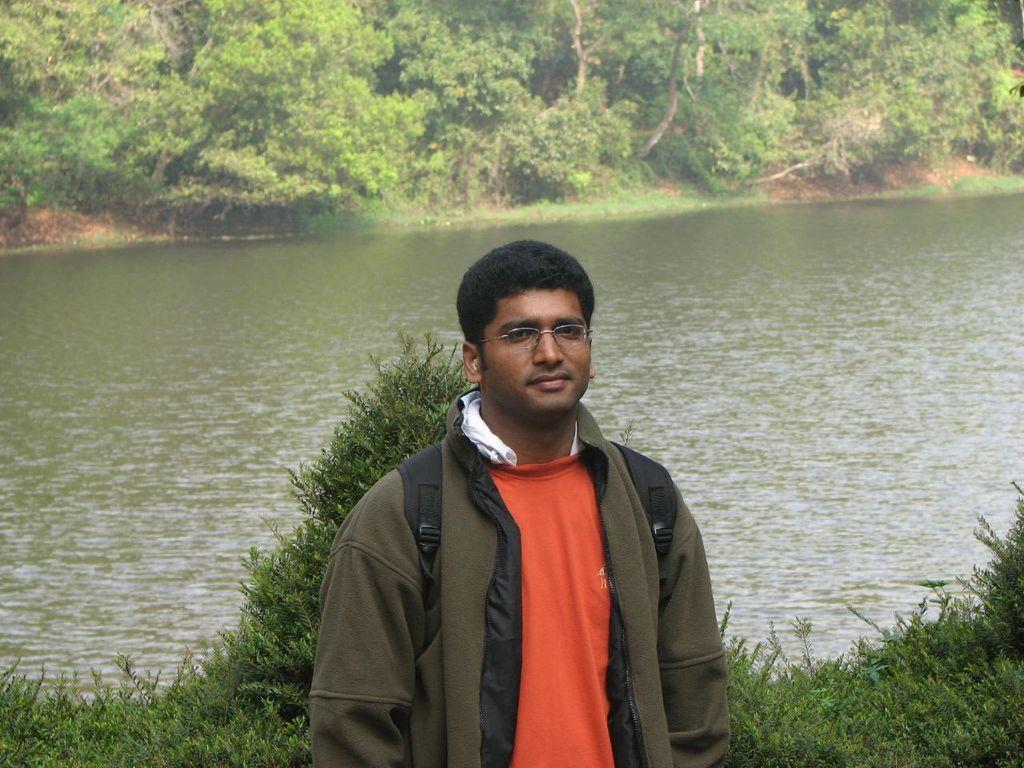Describe this image in one or two sentences. In this image we can see there is a man wearing jacket is standing at the bank of river which is surrounded with so many trees. 